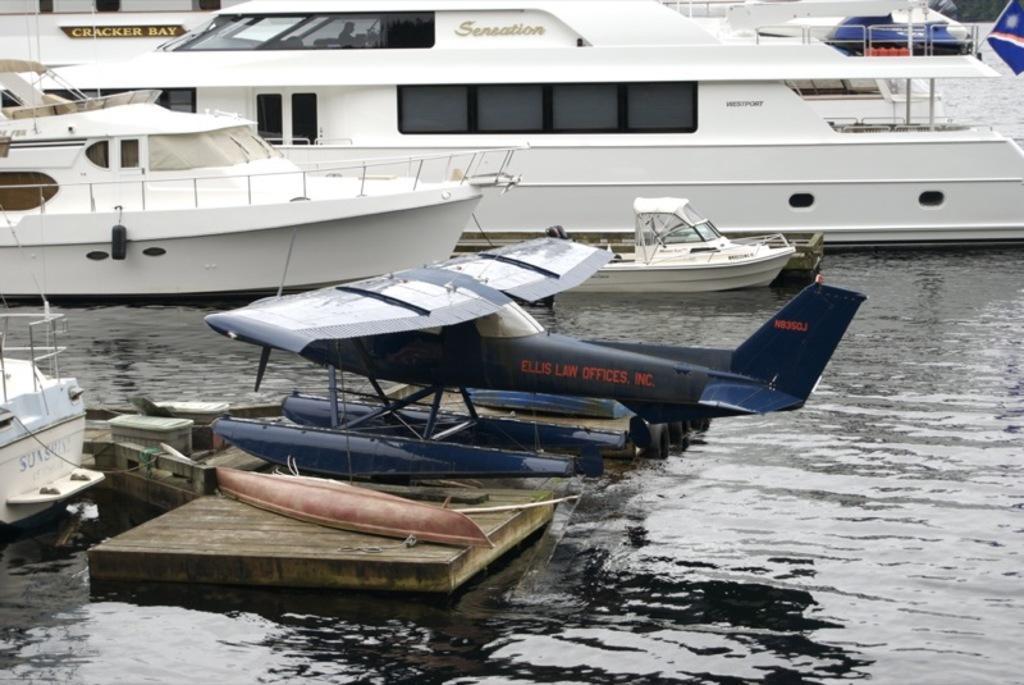Can you describe this image briefly? In this picture i can see many boats on the water. In the center there is a chopper which is parked on the wooden rafter. On the left i can see some fencing on the boat. On the top right corner i can see the trees. 